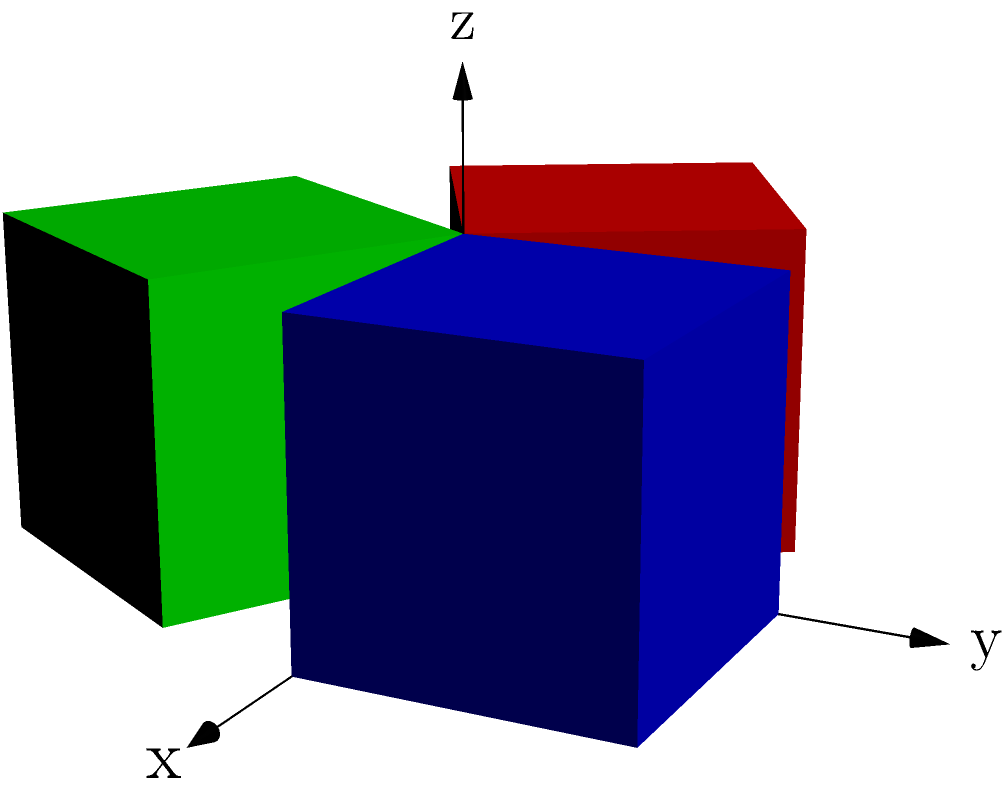In a 3D game engine, a character model is represented by a cube. The game allows for rotations around the z-axis in multiples of 120°. How many unique orientations of the cube can be achieved using only these rotations, and what group structure does this rotation system form? To solve this problem, let's follow these steps:

1. Identify the possible rotations:
   - 0° rotation (identity)
   - 120° rotation
   - 240° rotation

2. Count the unique orientations:
   - The cube has 3 unique orientations under these rotations, as shown in the diagram (blue, red, and green cubes).

3. Analyze the group structure:
   - Let's denote the rotations as follows:
     e: 0° rotation (identity)
     r: 120° rotation
     r²: 240° rotation

   - The group operation table:
     $$\begin{array}{c|ccc}
     \cdot & e & r & r^2 \\
     \hline
     e & e & r & r^2 \\
     r & r & r^2 & e \\
     r^2 & r^2 & e & r
     \end{array}$$

   - This group has the following properties:
     a) Closure: All combinations of rotations result in one of the three rotations.
     b) Associativity: $(a \cdot b) \cdot c = a \cdot (b \cdot c)$ for all elements.
     c) Identity: $e \cdot a = a \cdot e = a$ for all elements.
     d) Inverse: Each element has an inverse (e.g., $r \cdot r^2 = e$).

4. Identify the group:
   - This group has 3 elements and is cyclic.
   - It is isomorphic to the cyclic group $C_3$ or $\mathbb{Z}_3$.

Therefore, the rotation system forms a cyclic group of order 3, which is isomorphic to $C_3$ or $\mathbb{Z}_3$.
Answer: 3 unique orientations; Cyclic group $C_3$ 